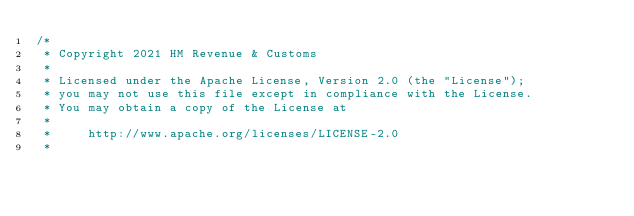Convert code to text. <code><loc_0><loc_0><loc_500><loc_500><_Scala_>/*
 * Copyright 2021 HM Revenue & Customs
 *
 * Licensed under the Apache License, Version 2.0 (the "License");
 * you may not use this file except in compliance with the License.
 * You may obtain a copy of the License at
 *
 *     http://www.apache.org/licenses/LICENSE-2.0
 *</code> 